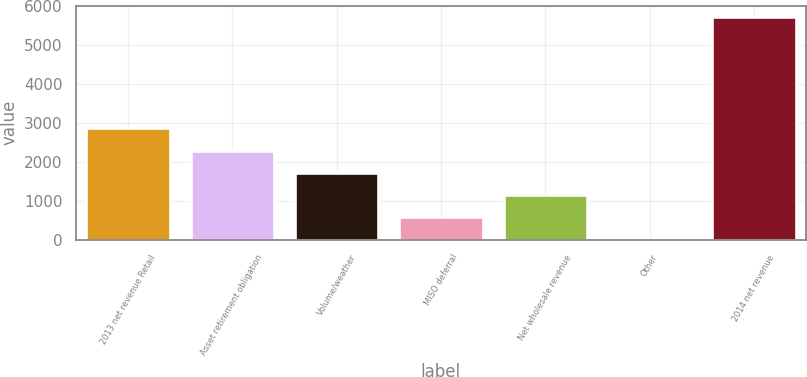<chart> <loc_0><loc_0><loc_500><loc_500><bar_chart><fcel>2013 net revenue Retail<fcel>Asset retirement obligation<fcel>Volume/weather<fcel>MISO deferral<fcel>Net wholesale revenue<fcel>Other<fcel>2014 net revenue<nl><fcel>2869<fcel>2295.8<fcel>1722.6<fcel>576.2<fcel>1149.4<fcel>3<fcel>5735<nl></chart> 